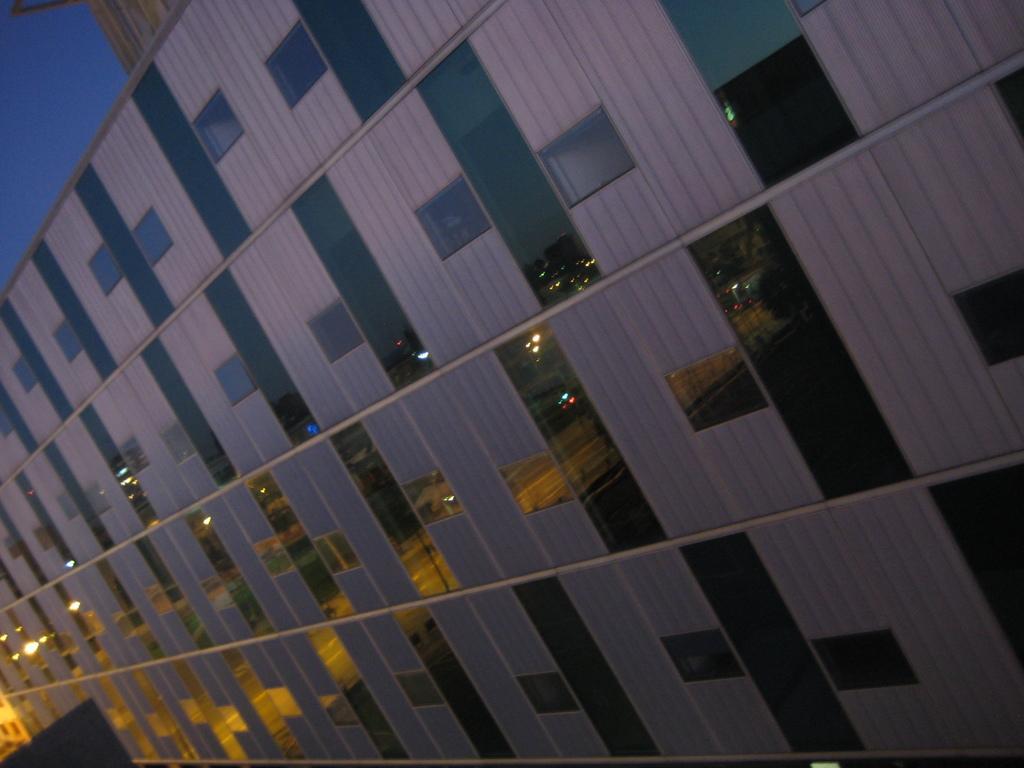Could you give a brief overview of what you see in this image? In this picture we can see the partition which is designed in box shape. In the background we can see the road, street lights, grass, plants and trees. On the left there is a sky. 